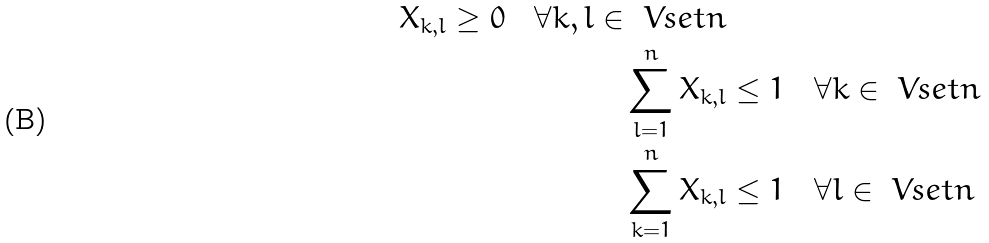<formula> <loc_0><loc_0><loc_500><loc_500>X _ { k , l } \geq 0 \quad \forall k , l \in \ V s e t n \\ \sum _ { l = 1 } ^ { n } X _ { k , l } & \leq 1 \quad \forall k \in \ V s e t n \\ \sum _ { k = 1 } ^ { n } X _ { k , l } & \leq 1 \quad \forall l \in \ V s e t n</formula> 